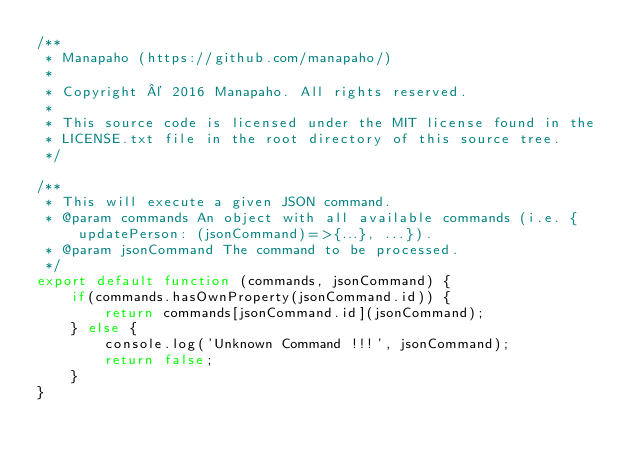<code> <loc_0><loc_0><loc_500><loc_500><_JavaScript_>/**
 * Manapaho (https://github.com/manapaho/)
 *
 * Copyright © 2016 Manapaho. All rights reserved.
 *
 * This source code is licensed under the MIT license found in the
 * LICENSE.txt file in the root directory of this source tree.
 */

/**
 * This will execute a given JSON command.
 * @param commands An object with all available commands (i.e. {updatePerson: (jsonCommand)=>{...}, ...}).
 * @param jsonCommand The command to be processed.
 */
export default function (commands, jsonCommand) {
    if(commands.hasOwnProperty(jsonCommand.id)) {
        return commands[jsonCommand.id](jsonCommand);
    } else {
        console.log('Unknown Command !!!', jsonCommand);
        return false;
    }
}
</code> 